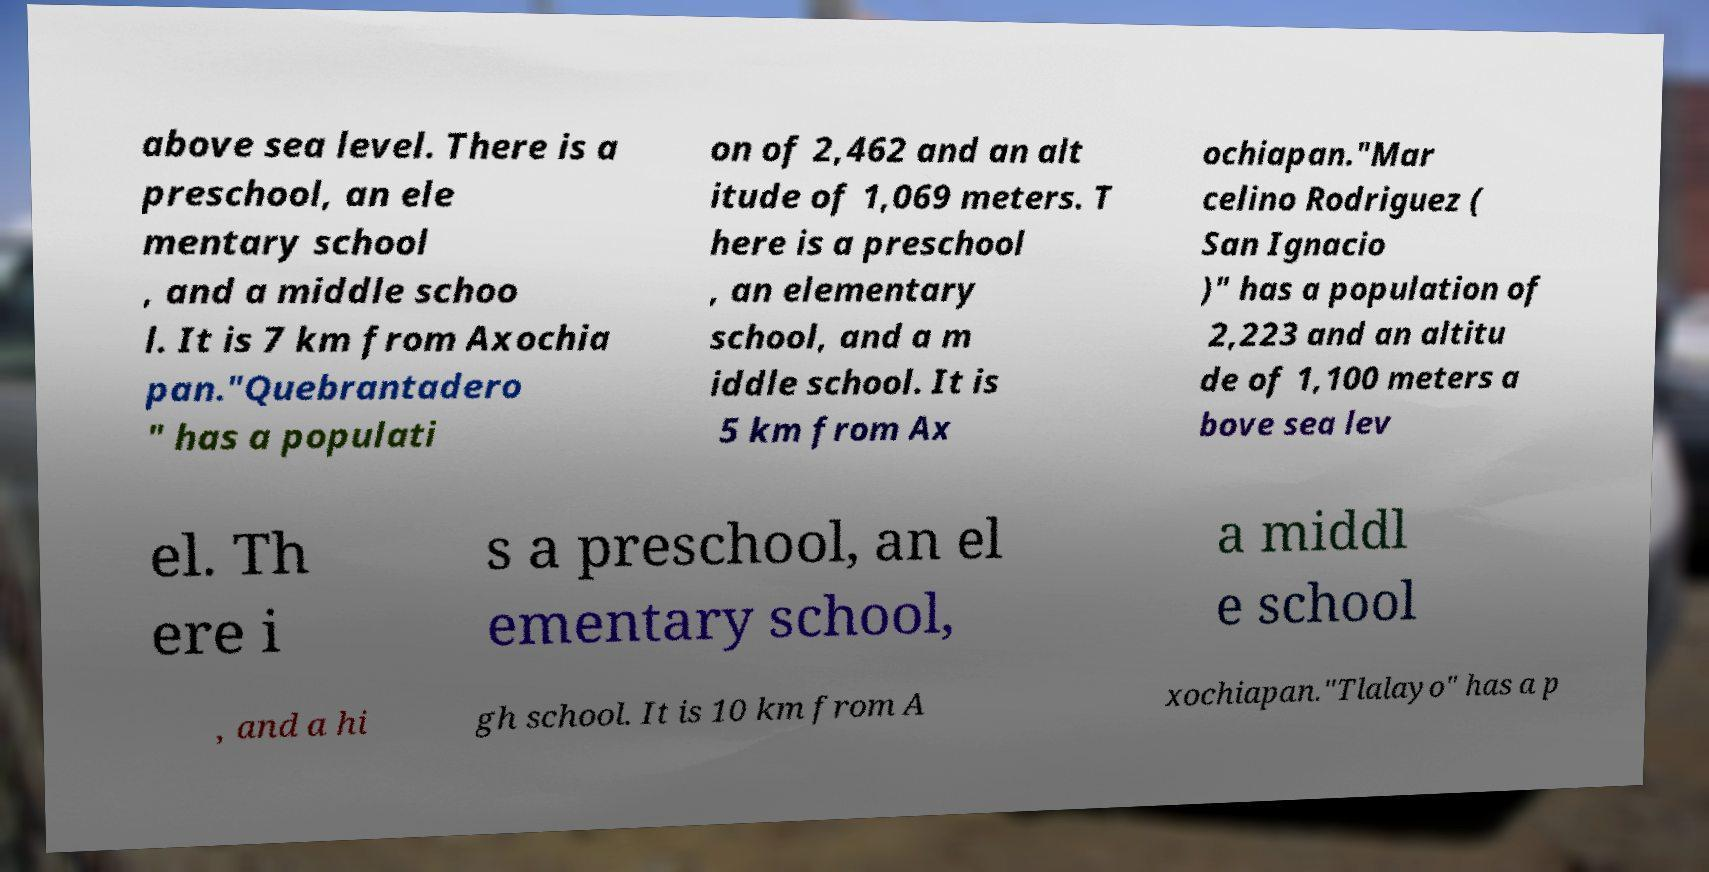There's text embedded in this image that I need extracted. Can you transcribe it verbatim? above sea level. There is a preschool, an ele mentary school , and a middle schoo l. It is 7 km from Axochia pan."Quebrantadero " has a populati on of 2,462 and an alt itude of 1,069 meters. T here is a preschool , an elementary school, and a m iddle school. It is 5 km from Ax ochiapan."Mar celino Rodriguez ( San Ignacio )" has a population of 2,223 and an altitu de of 1,100 meters a bove sea lev el. Th ere i s a preschool, an el ementary school, a middl e school , and a hi gh school. It is 10 km from A xochiapan."Tlalayo" has a p 